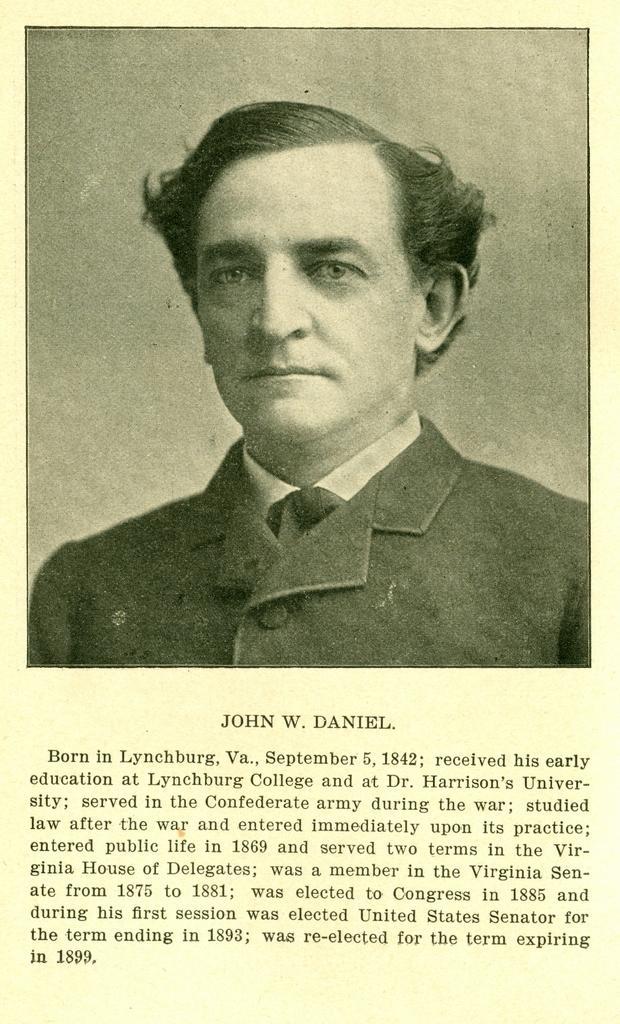Could you give a brief overview of what you see in this image? In this image I can see there is a picture of a man, he is wearing a black coat and looking at left side. The backdrop of image is plain surface. There is something written at the bottom of the image. 